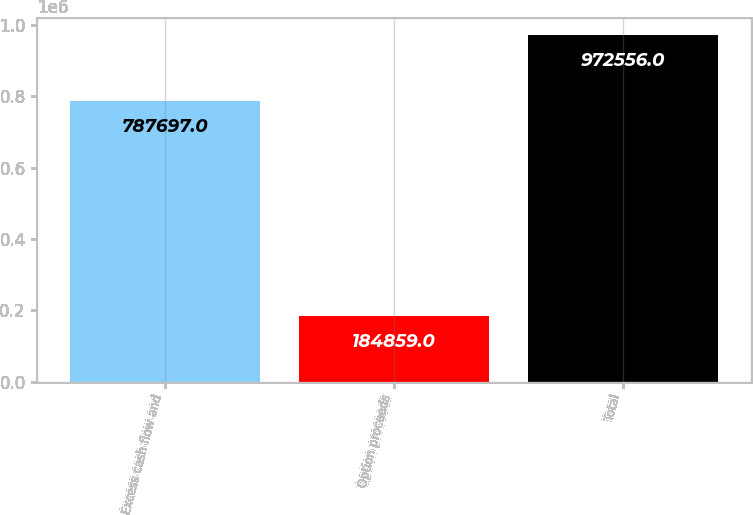Convert chart. <chart><loc_0><loc_0><loc_500><loc_500><bar_chart><fcel>Excess cash flow and<fcel>Option proceeds<fcel>Total<nl><fcel>787697<fcel>184859<fcel>972556<nl></chart> 